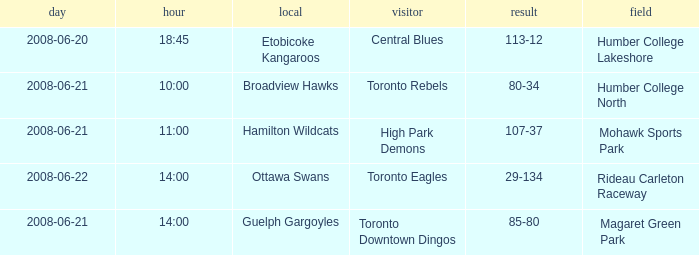What is the Time with a Ground that is humber college north? 10:00. 